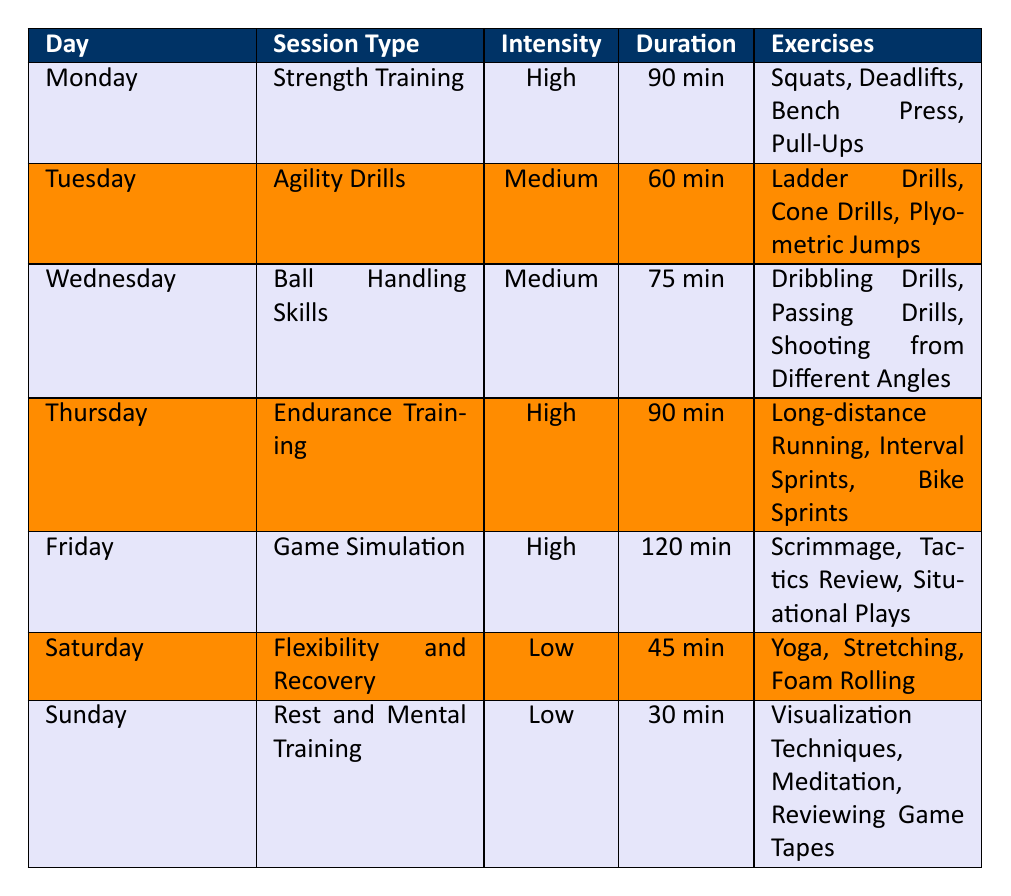What is the duration of the Game Simulation session? The Game Simulation session is listed under Friday with a duration of 120 minutes.
Answer: 120 min Which day has the highest intensity level training? Both Monday (Strength Training), Thursday (Endurance Training), and Friday (Game Simulation) have a high intensity level, but Monday is the first row and refers to the same level.
Answer: Monday, Thursday, and Friday What total duration do you spend on strength training and endurance training combined? Strength Training lasts 90 minutes on Monday, and Endurance Training lasts 90 minutes on Thursday. Adding these gives 90 + 90 = 180 minutes total.
Answer: 180 min Is the Ball Handling Skills session longer than the Flexibility and Recovery session? The Ball Handling Skills session on Wednesday lasts 75 minutes, while the Flexibility and Recovery session on Saturday lasts 45 minutes. Since 75 is greater than 45, the statement is true.
Answer: Yes On which day do you perform Agility Drills, and what is its intensity level? Agility Drills are scheduled for Tuesday, and the intensity level for this session is medium.
Answer: Tuesday, Medium What is the average duration of the sessions dedicated to low-intensity training? There are two low-intensity sessions: Flexibility and Recovery lasting 45 minutes and Rest and Mental Training lasting 30 minutes. The average is (45 + 30) / 2 = 37.5 minutes.
Answer: 37.5 min Which session includes yoga? The session that includes yoga is Flexibility and Recovery, scheduled for Saturday.
Answer: Flexibility and Recovery How many exercises are performed on average during high-intensity sessions? There are three sessions with high intensity: Strength Training (4 exercises), Endurance Training (3 exercises), and Game Simulation (3 exercises). The total is 4 + 3 + 3 = 10, and the average is 10 / 3 ≈ 3.33, which is about 3 exercises.
Answer: About 3 exercises 